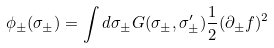<formula> <loc_0><loc_0><loc_500><loc_500>\phi _ { \pm } ( \sigma _ { \pm } ) = \int d \sigma _ { \pm } G ( \sigma _ { \pm } , \sigma _ { \pm } ^ { \prime } ) \frac { 1 } { 2 } ( \partial _ { \pm } f ) ^ { 2 }</formula> 